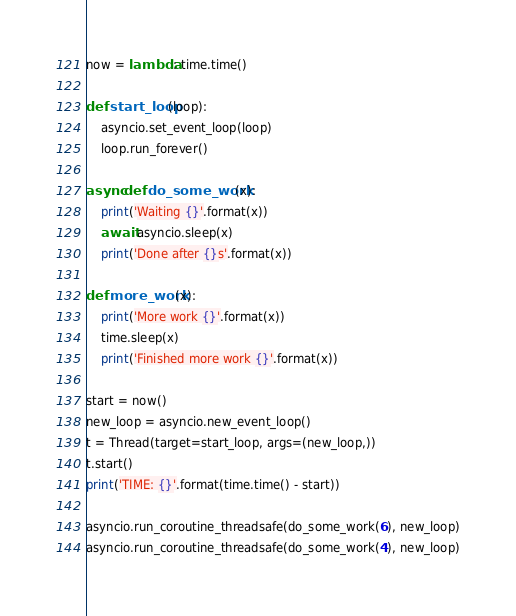Convert code to text. <code><loc_0><loc_0><loc_500><loc_500><_Python_>
now = lambda: time.time()

def start_loop(loop):
    asyncio.set_event_loop(loop)
    loop.run_forever()

async def do_some_work(x):
    print('Waiting {}'.format(x))
    await asyncio.sleep(x)
    print('Done after {}s'.format(x))

def more_work(x):
    print('More work {}'.format(x))
    time.sleep(x)
    print('Finished more work {}'.format(x))

start = now()
new_loop = asyncio.new_event_loop()
t = Thread(target=start_loop, args=(new_loop,))
t.start()
print('TIME: {}'.format(time.time() - start))

asyncio.run_coroutine_threadsafe(do_some_work(6), new_loop)
asyncio.run_coroutine_threadsafe(do_some_work(4), new_loop)
</code> 